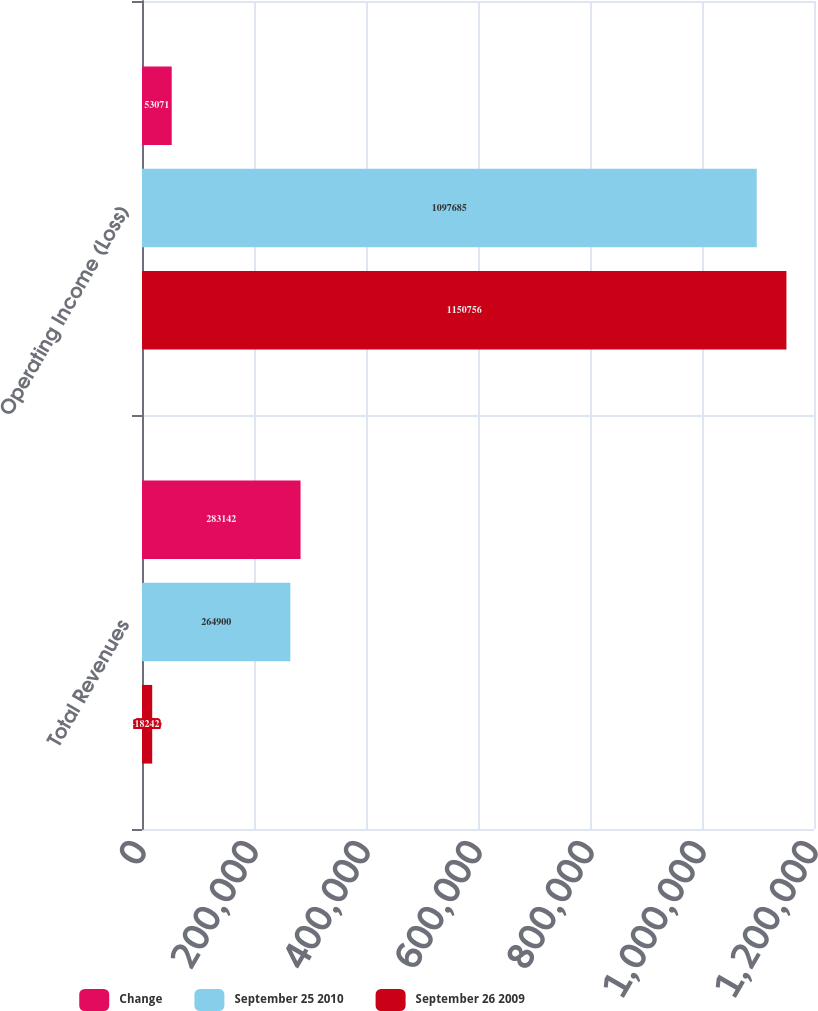<chart> <loc_0><loc_0><loc_500><loc_500><stacked_bar_chart><ecel><fcel>Total Revenues<fcel>Operating Income (Loss)<nl><fcel>Change<fcel>283142<fcel>53071<nl><fcel>September 25 2010<fcel>264900<fcel>1.09768e+06<nl><fcel>September 26 2009<fcel>18242<fcel>1.15076e+06<nl></chart> 